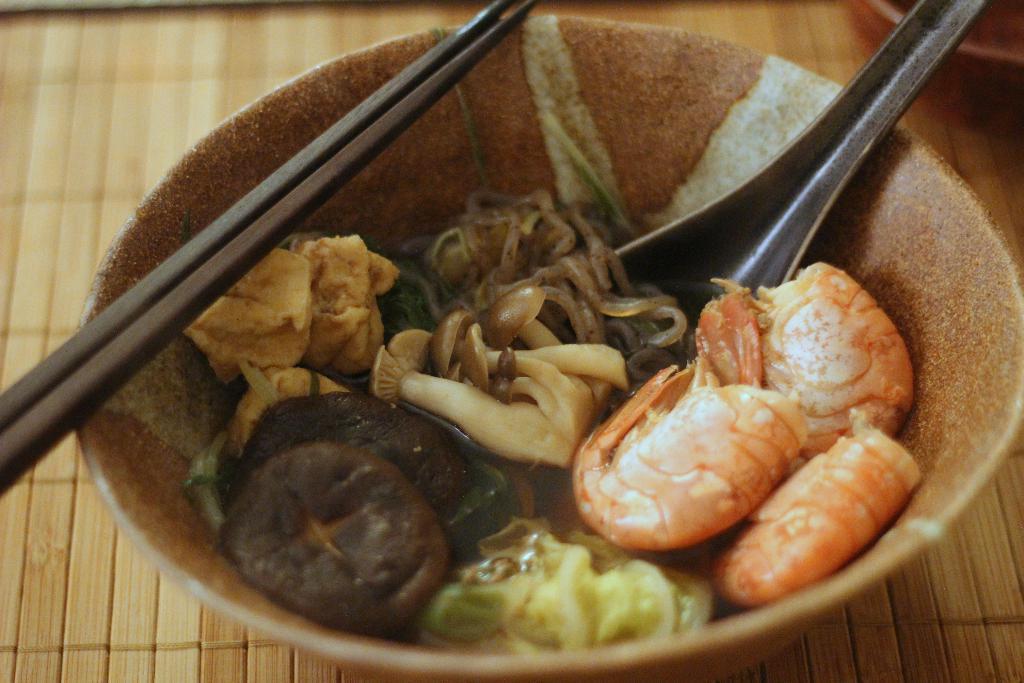Describe this image in one or two sentences. Here we can see a bowl having food in it with a spoon and chopsticks present on it 